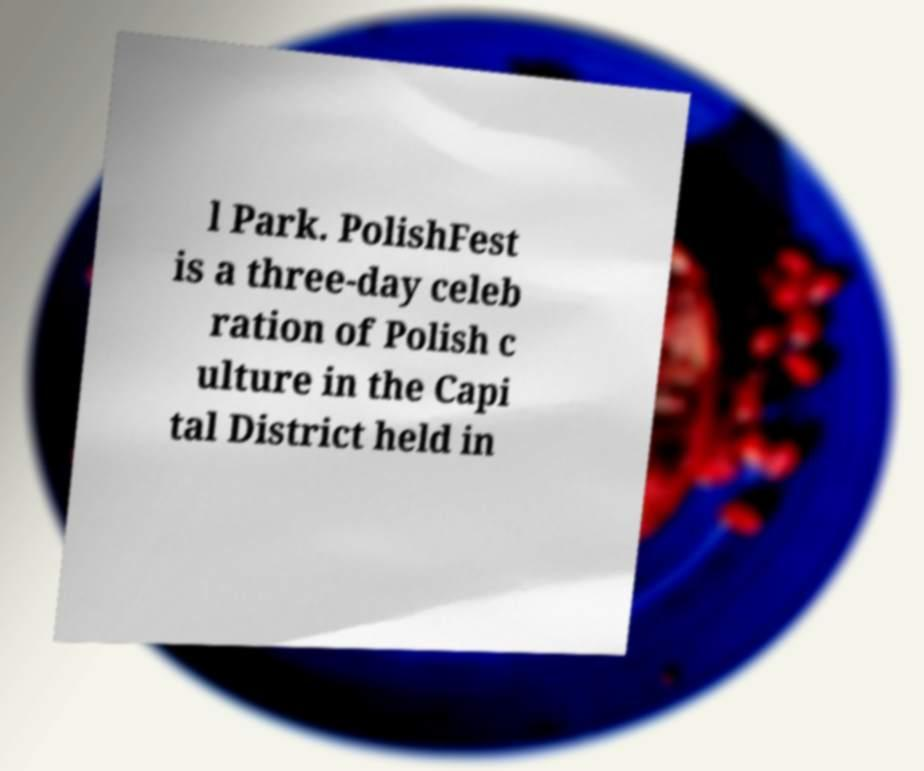There's text embedded in this image that I need extracted. Can you transcribe it verbatim? l Park. PolishFest is a three-day celeb ration of Polish c ulture in the Capi tal District held in 